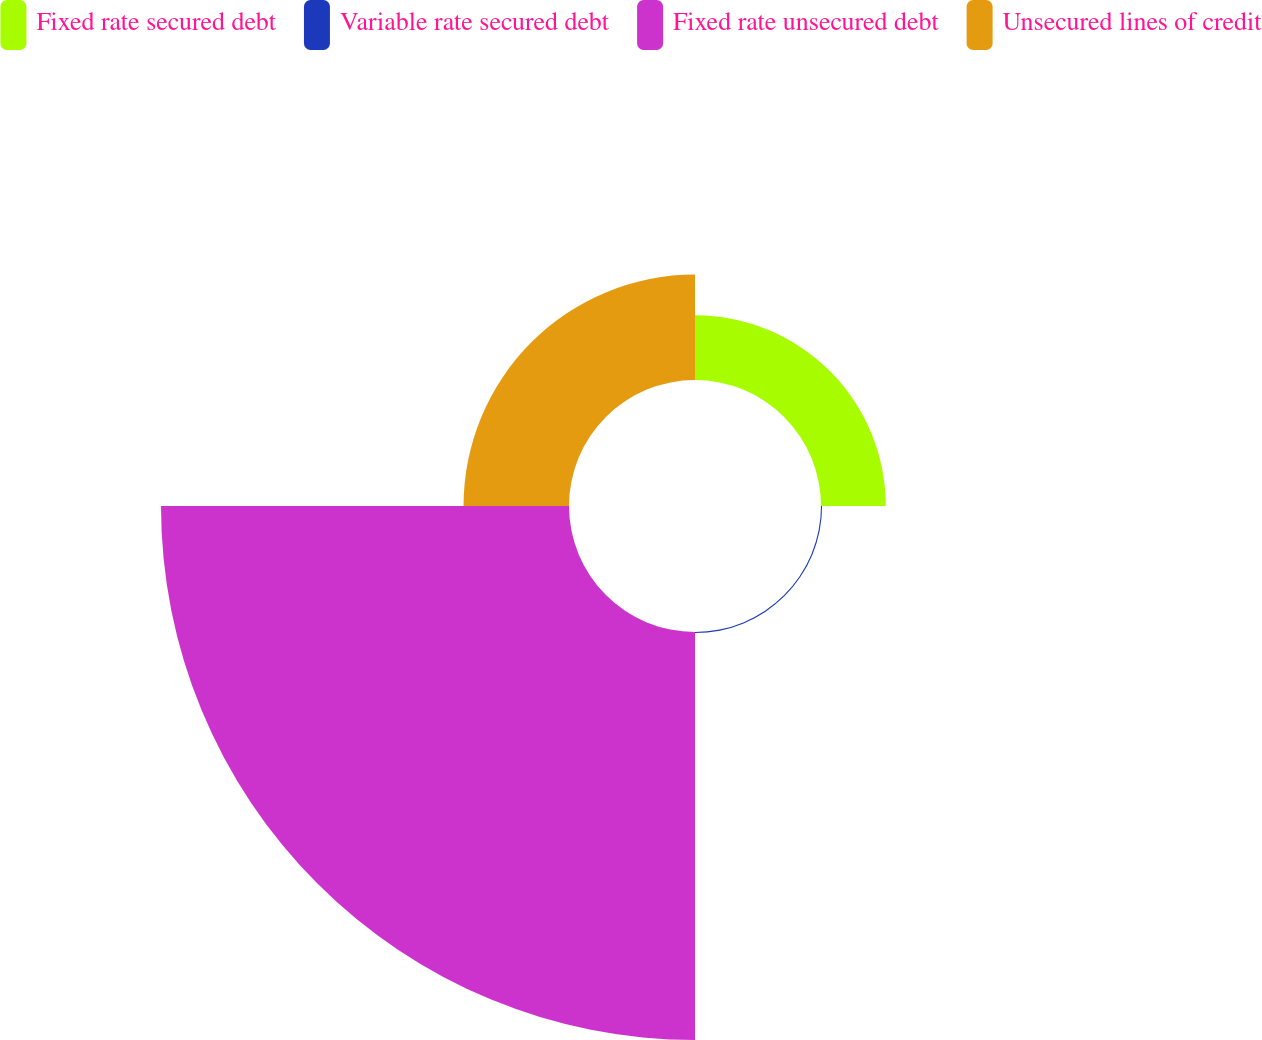Convert chart. <chart><loc_0><loc_0><loc_500><loc_500><pie_chart><fcel>Fixed rate secured debt<fcel>Variable rate secured debt<fcel>Fixed rate unsecured debt<fcel>Unsecured lines of credit<nl><fcel>11.18%<fcel>0.19%<fcel>70.42%<fcel>18.2%<nl></chart> 